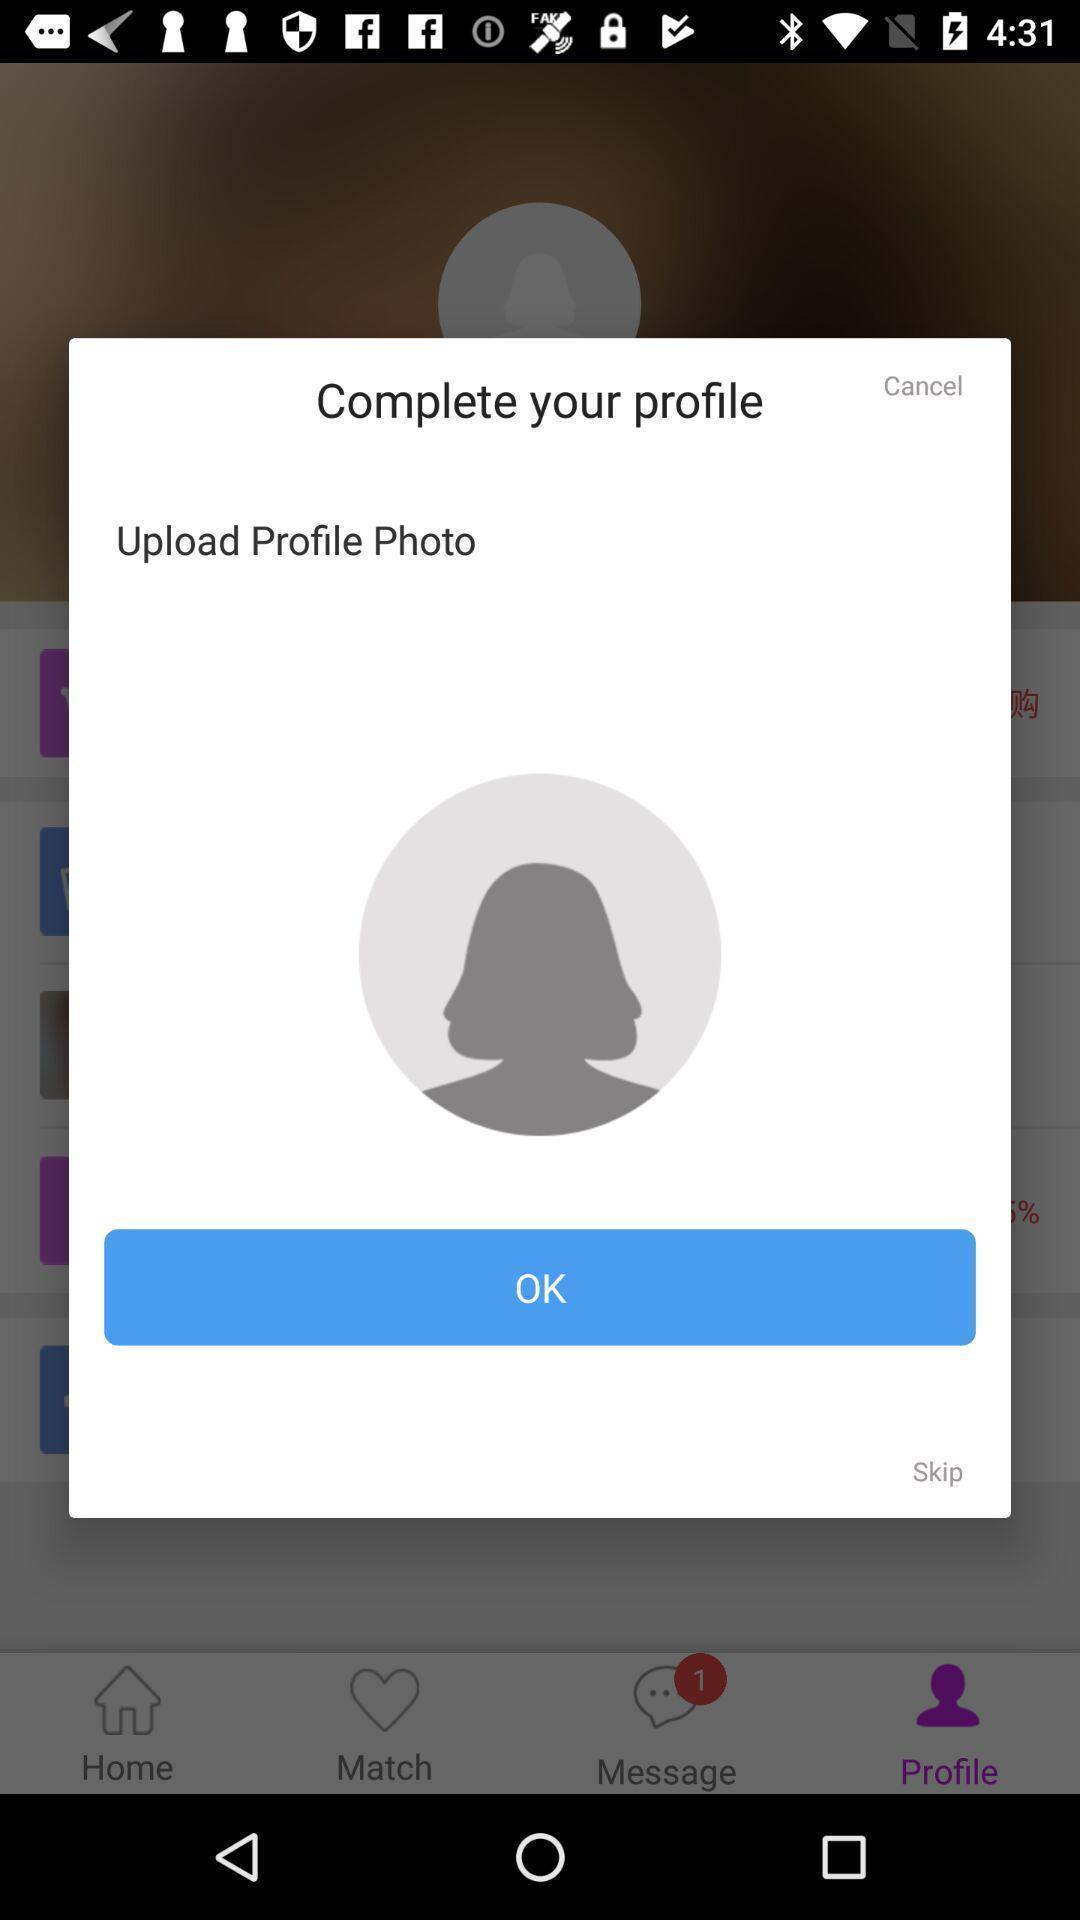Tell me about the visual elements in this screen capture. Popup of profile to update it. 